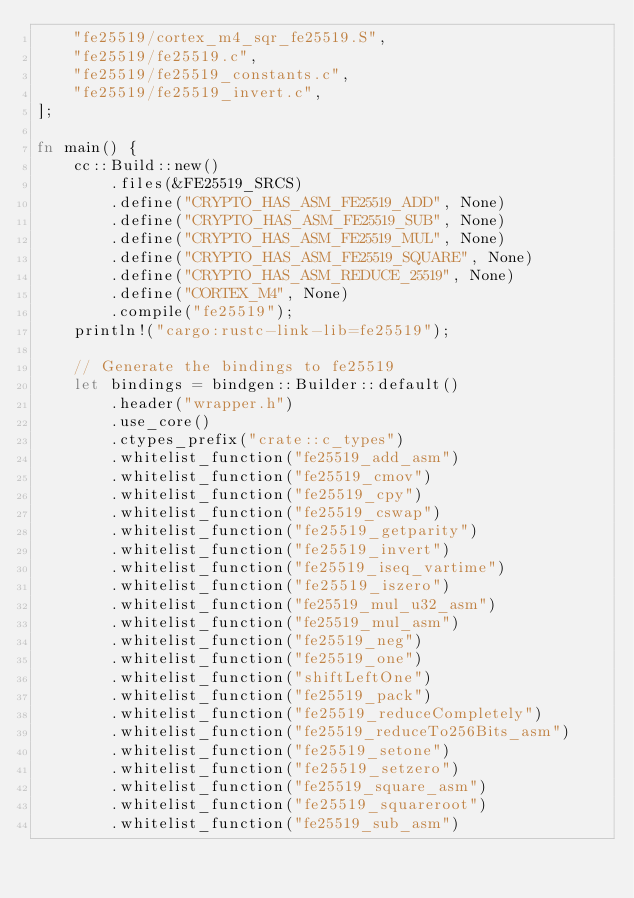Convert code to text. <code><loc_0><loc_0><loc_500><loc_500><_Rust_>    "fe25519/cortex_m4_sqr_fe25519.S",
    "fe25519/fe25519.c",
    "fe25519/fe25519_constants.c",
    "fe25519/fe25519_invert.c",
];

fn main() {
    cc::Build::new()
        .files(&FE25519_SRCS)
        .define("CRYPTO_HAS_ASM_FE25519_ADD", None)
        .define("CRYPTO_HAS_ASM_FE25519_SUB", None)
        .define("CRYPTO_HAS_ASM_FE25519_MUL", None)
        .define("CRYPTO_HAS_ASM_FE25519_SQUARE", None)
        .define("CRYPTO_HAS_ASM_REDUCE_25519", None)
        .define("CORTEX_M4", None)
        .compile("fe25519");
    println!("cargo:rustc-link-lib=fe25519");

    // Generate the bindings to fe25519
    let bindings = bindgen::Builder::default()
        .header("wrapper.h")
        .use_core()
        .ctypes_prefix("crate::c_types")
        .whitelist_function("fe25519_add_asm")
        .whitelist_function("fe25519_cmov")
        .whitelist_function("fe25519_cpy")
        .whitelist_function("fe25519_cswap")
        .whitelist_function("fe25519_getparity")
        .whitelist_function("fe25519_invert")
        .whitelist_function("fe25519_iseq_vartime")
        .whitelist_function("fe25519_iszero")
        .whitelist_function("fe25519_mul_u32_asm")
        .whitelist_function("fe25519_mul_asm")
        .whitelist_function("fe25519_neg")
        .whitelist_function("fe25519_one")
        .whitelist_function("shiftLeftOne")
        .whitelist_function("fe25519_pack")
        .whitelist_function("fe25519_reduceCompletely")
        .whitelist_function("fe25519_reduceTo256Bits_asm")
        .whitelist_function("fe25519_setone")
        .whitelist_function("fe25519_setzero")
        .whitelist_function("fe25519_square_asm")
        .whitelist_function("fe25519_squareroot")
        .whitelist_function("fe25519_sub_asm")</code> 